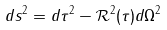<formula> <loc_0><loc_0><loc_500><loc_500>d s ^ { 2 } = d \tau ^ { 2 } - { \mathcal { R } } ^ { 2 } ( \tau ) d \Omega ^ { 2 }</formula> 